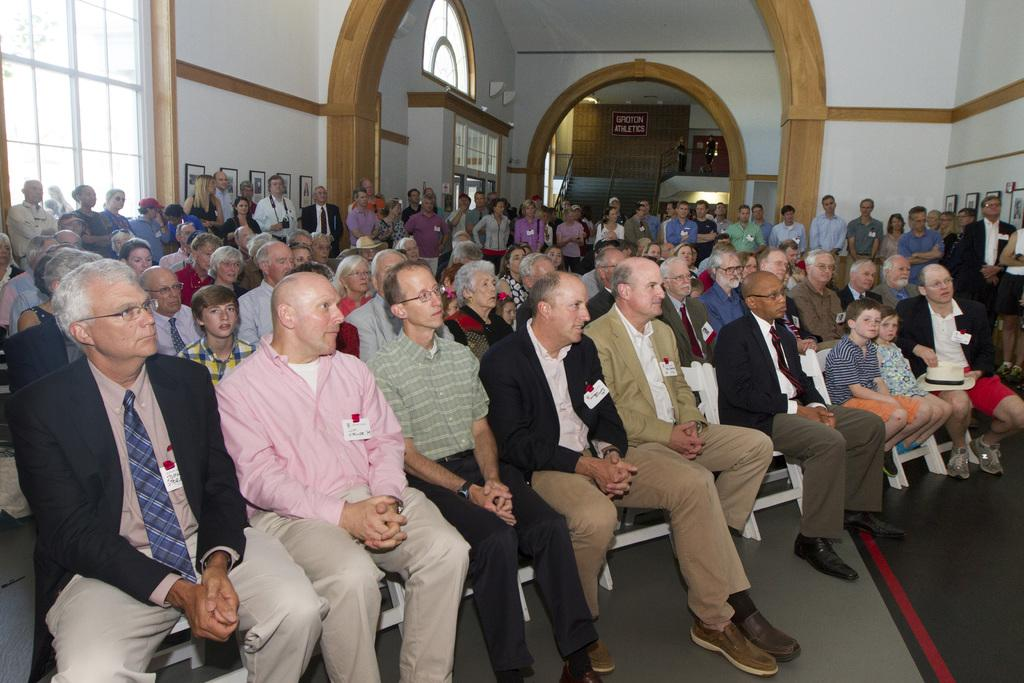How many people are in the image? There is a group of persons in the image. What are the people in the image doing? Some of the persons are sitting on chairs, while others are standing on the floor. Can you describe the building in the image? The building has glass windows and white walls. What type of coil is being used to cook dinner in the image? There is no coil or dinner present in the image. How many people are sitting at the table for dinner in the image? There is no table or dinner present in the image, so it is not possible to determine the number of people who might be sitting at a table. 